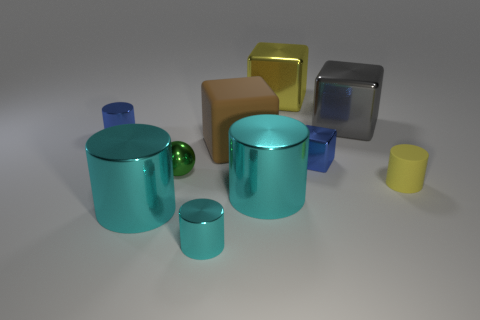What is the color of the large cube that is made of the same material as the big gray thing?
Ensure brevity in your answer.  Yellow. There is a small metallic thing on the right side of the large yellow cube; is its shape the same as the yellow object behind the large rubber object?
Make the answer very short. Yes. What number of matte things are either small blue cubes or big brown objects?
Offer a terse response. 1. There is a big cube that is the same color as the small matte cylinder; what is it made of?
Your answer should be compact. Metal. Is there anything else that has the same shape as the small cyan shiny thing?
Make the answer very short. Yes. What material is the cube that is in front of the brown rubber object?
Provide a short and direct response. Metal. Does the brown cube that is behind the green metal thing have the same material as the small yellow cylinder?
Provide a short and direct response. Yes. What number of objects are either large yellow blocks or cyan things that are left of the matte block?
Keep it short and to the point. 3. What is the size of the blue metal object that is the same shape as the small yellow rubber thing?
Offer a terse response. Small. Are there any small things right of the green object?
Your answer should be very brief. Yes. 